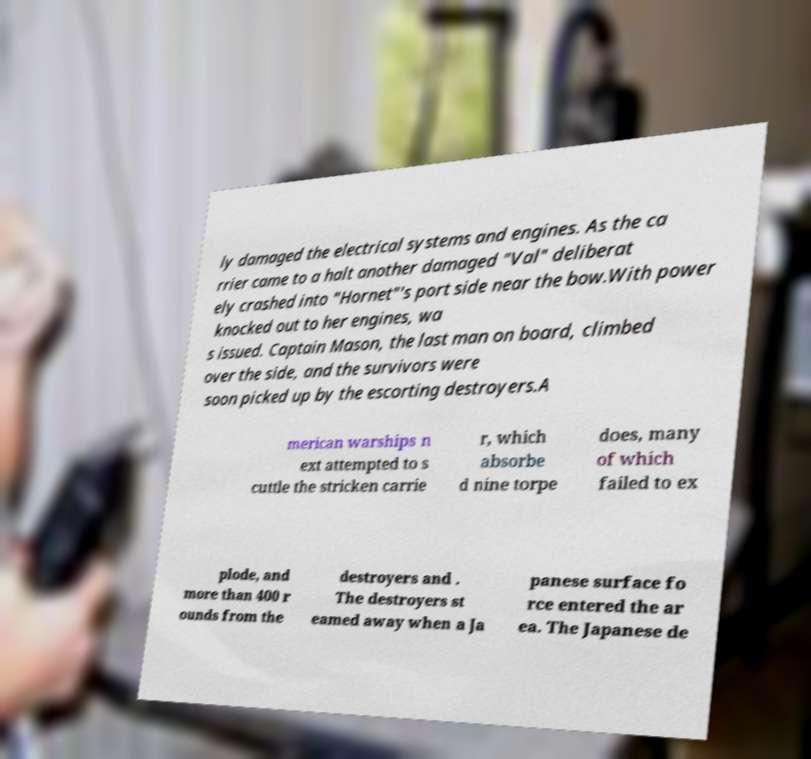There's text embedded in this image that I need extracted. Can you transcribe it verbatim? ly damaged the electrical systems and engines. As the ca rrier came to a halt another damaged "Val" deliberat ely crashed into "Hornet"'s port side near the bow.With power knocked out to her engines, wa s issued. Captain Mason, the last man on board, climbed over the side, and the survivors were soon picked up by the escorting destroyers.A merican warships n ext attempted to s cuttle the stricken carrie r, which absorbe d nine torpe does, many of which failed to ex plode, and more than 400 r ounds from the destroyers and . The destroyers st eamed away when a Ja panese surface fo rce entered the ar ea. The Japanese de 